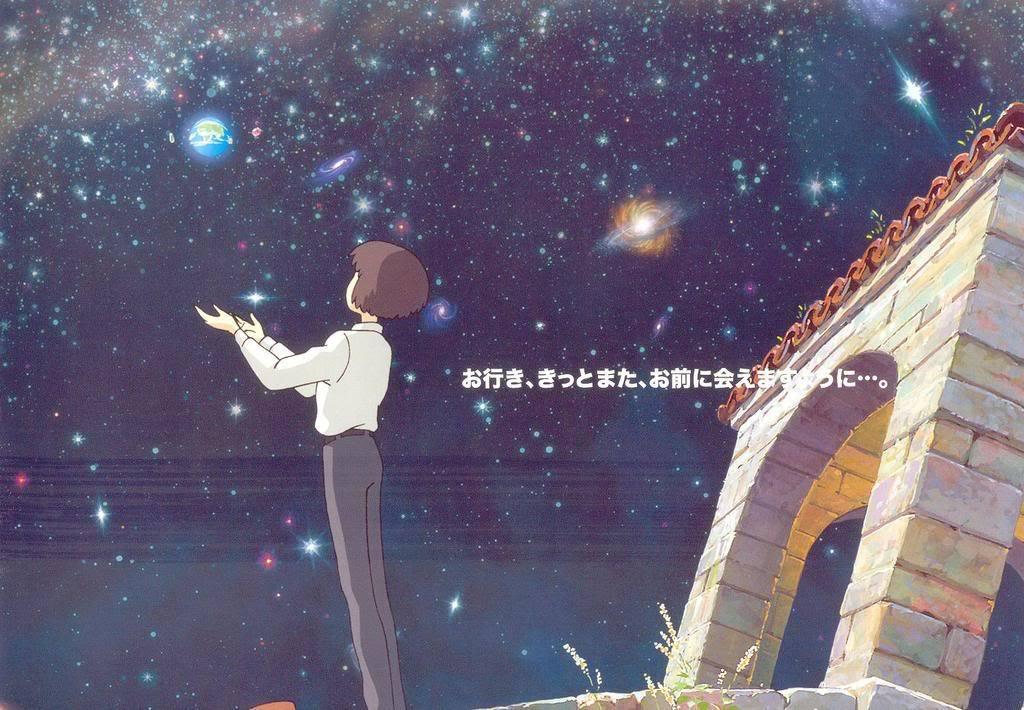What type of image is depicted in the picture? There is a cartoon image of a boy in the picture. What is the boy doing in the image? The boy is standing and showing his hands to the sky. What can be seen in the sky in the image? The sky is full of stars. What is located behind the boy in the image? There is a gateway behind the boy. What sense does the boy use to interact with the ducks in the image? There are no ducks present in the image, and therefore the boy does not interact with any ducks. How old is the boy's daughter in the image? There is no mention of a daughter in the image, so we cannot determine her age. 